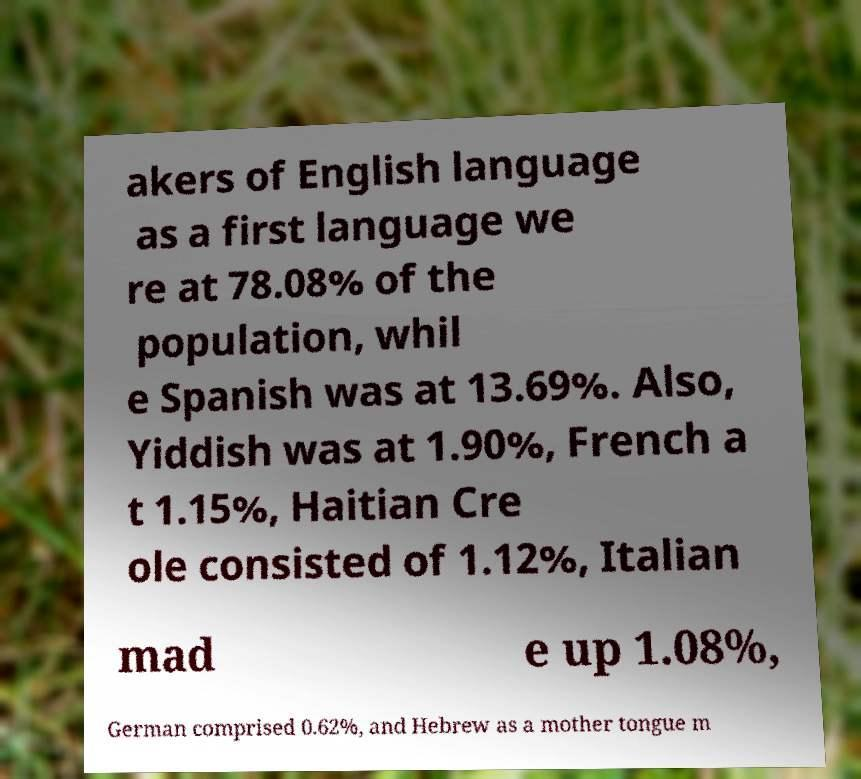Please read and relay the text visible in this image. What does it say? akers of English language as a first language we re at 78.08% of the population, whil e Spanish was at 13.69%. Also, Yiddish was at 1.90%, French a t 1.15%, Haitian Cre ole consisted of 1.12%, Italian mad e up 1.08%, German comprised 0.62%, and Hebrew as a mother tongue m 